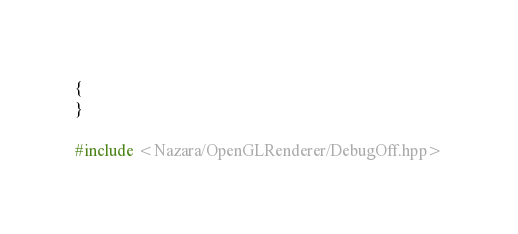<code> <loc_0><loc_0><loc_500><loc_500><_C++_>{
}

#include <Nazara/OpenGLRenderer/DebugOff.hpp>
</code> 